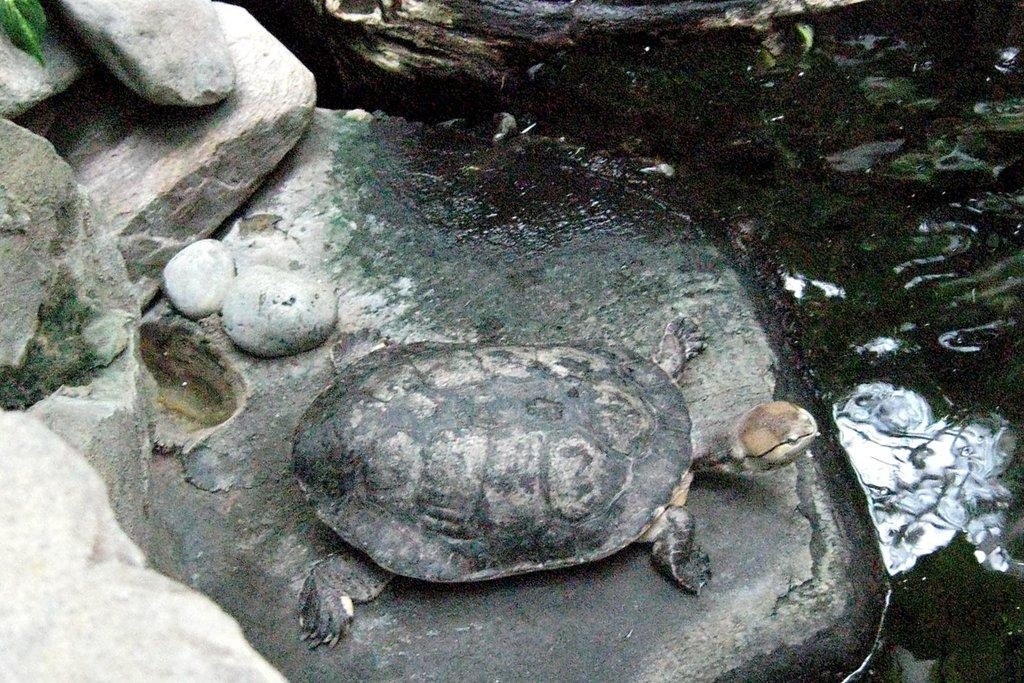What is the primary element in the image? There is water in the image. What other objects can be seen in the image? There are rocks, stones, and a tortoise in the image. Can you describe the vegetation in the image? There is a green leaf in the top left corner of the image. What type of pot is the goldfish swimming in within the image? There is no pot or goldfish present in the image. 